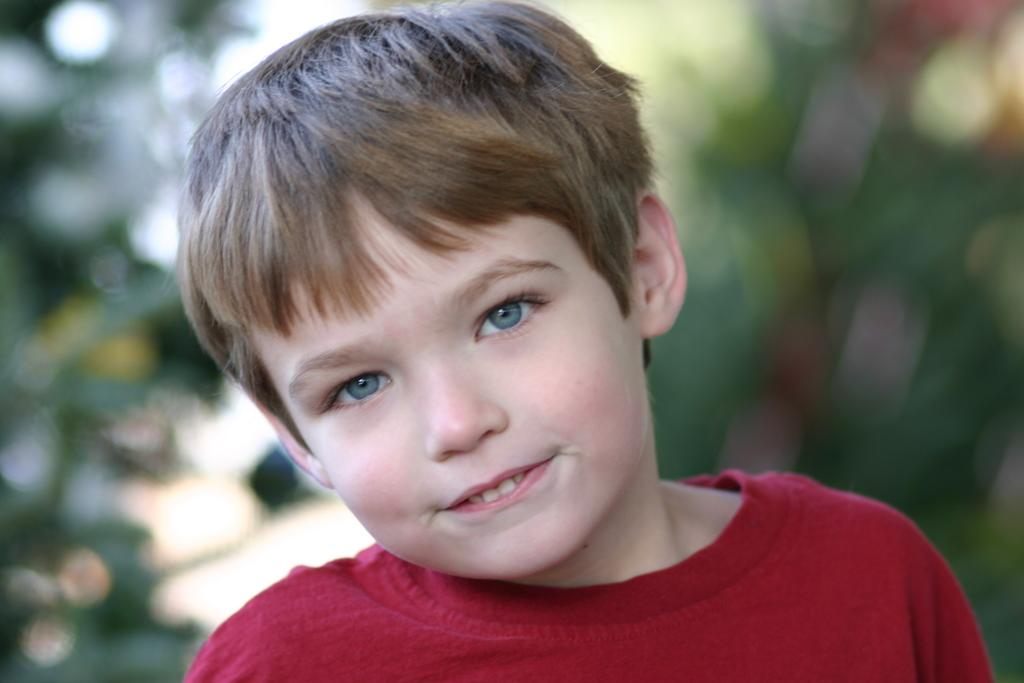What is the main subject of the image? There is a boy in the image. What is the boy wearing? The boy is wearing a red t-shirt. Can you describe the background of the image? The background of the image is blurry. How much coal is the boy holding in the image? There is no coal present in the image, so it cannot be determined how much the boy might be holding. 